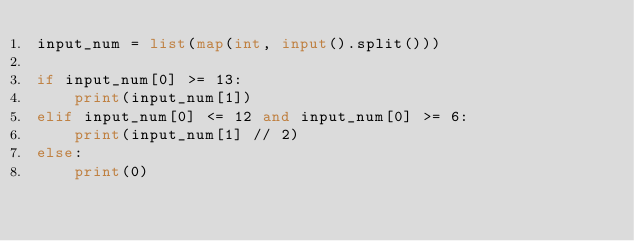<code> <loc_0><loc_0><loc_500><loc_500><_Python_>input_num = list(map(int, input().split()))

if input_num[0] >= 13:
    print(input_num[1])
elif input_num[0] <= 12 and input_num[0] >= 6:
    print(input_num[1] // 2)
else:
    print(0)
</code> 